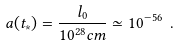<formula> <loc_0><loc_0><loc_500><loc_500>a ( t _ { * } ) = \frac { l _ { 0 } } { 1 0 ^ { 2 8 } c m } \simeq 1 0 ^ { - 5 6 } \ .</formula> 